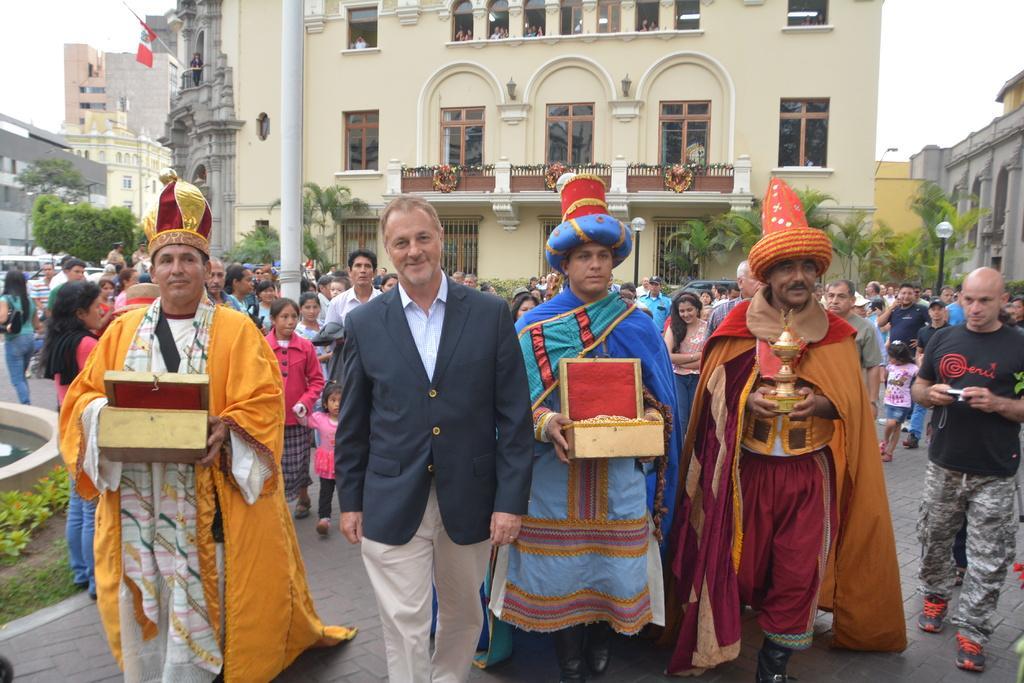Could you give a brief overview of what you see in this image? In this image we can see many persons walking on the road. In the background we can see pillar, buildings, flag and sky. 